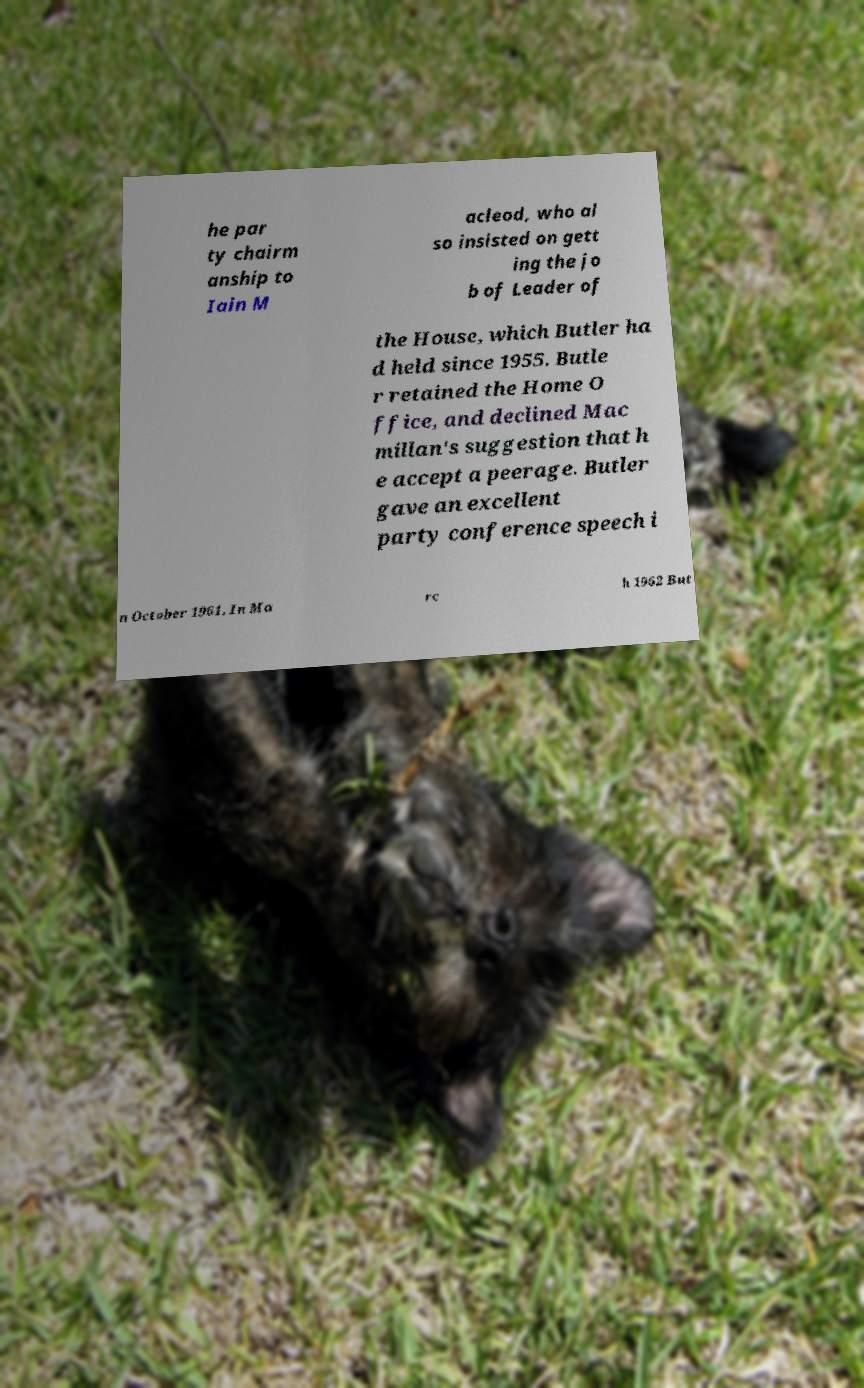Could you extract and type out the text from this image? he par ty chairm anship to Iain M acleod, who al so insisted on gett ing the jo b of Leader of the House, which Butler ha d held since 1955. Butle r retained the Home O ffice, and declined Mac millan's suggestion that h e accept a peerage. Butler gave an excellent party conference speech i n October 1961. In Ma rc h 1962 But 